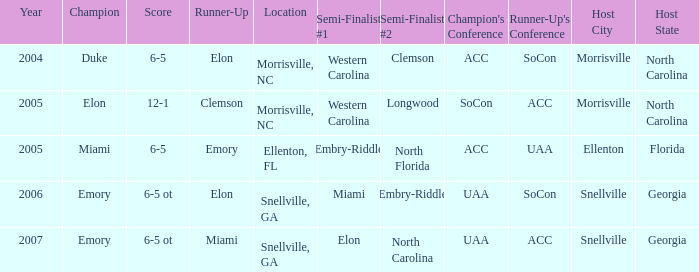When Embry-Riddle made it to the first semi finalist slot, list all the runners up. Emory. 